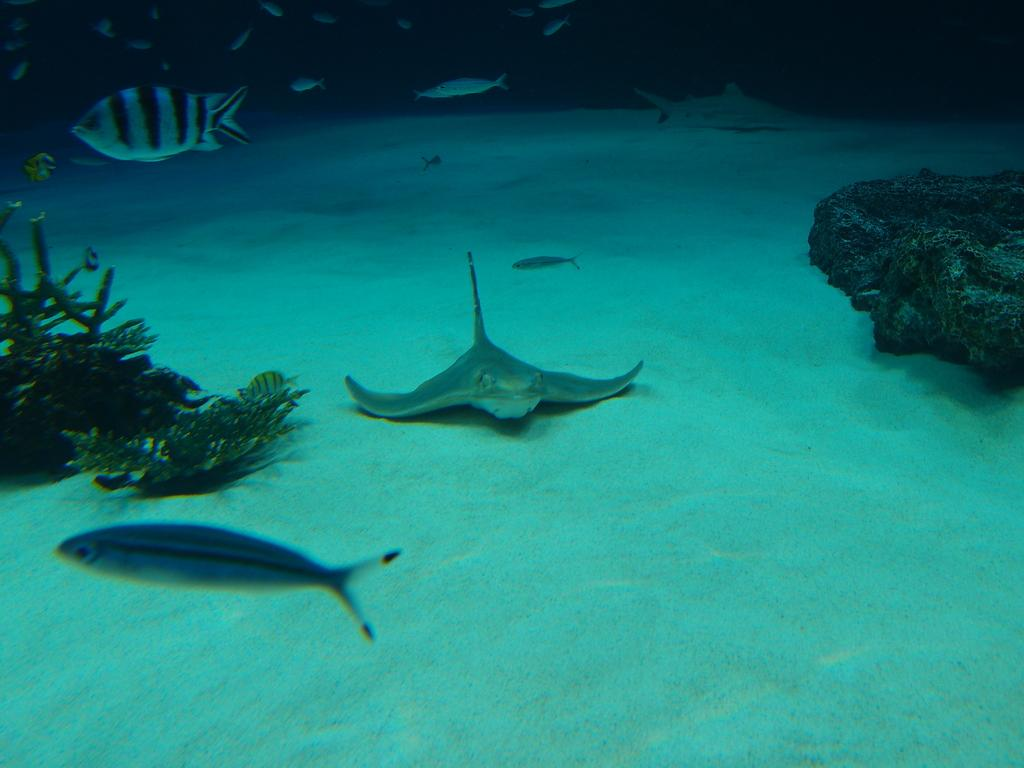What type of environment is shown in the image? The image depicts an underwater environment. What living organisms can be seen in the water? There are fishes in the water. Are there any non-living elements visible in the water? Yes, there are plants in the water. What is the primary substance visible in the image? Water is visible in the image. What type of cat can be seen climbing a hill in the image? There is no cat or hill present in the image; it depicts an underwater environment. 